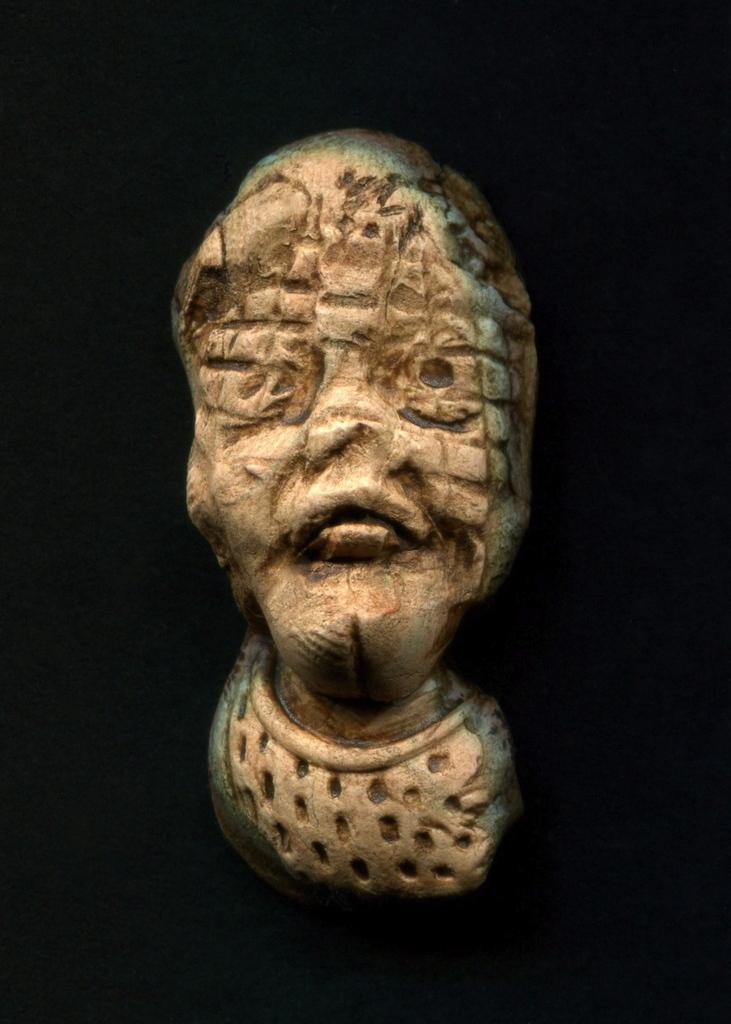What is the main subject of the image? There is a sculpture in the image. What material is the sculpture made of? The sculpture is made with stone. How many rings are visible on the sculpture in the image? There are no rings present on the sculpture in the image. What type of transport is used to move the sculpture in the image? The image does not depict the sculpture being moved, and therefore no transport is visible. 